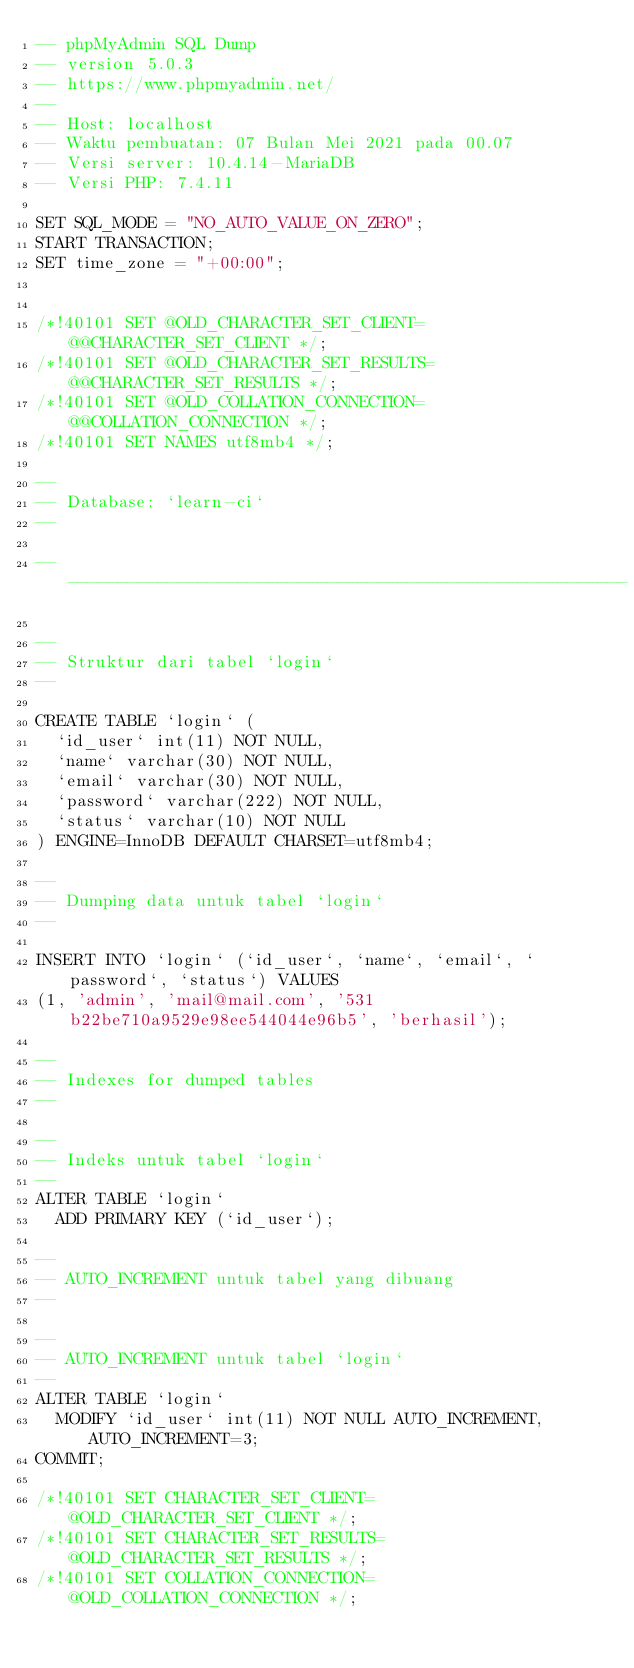<code> <loc_0><loc_0><loc_500><loc_500><_SQL_>-- phpMyAdmin SQL Dump
-- version 5.0.3
-- https://www.phpmyadmin.net/
--
-- Host: localhost
-- Waktu pembuatan: 07 Bulan Mei 2021 pada 00.07
-- Versi server: 10.4.14-MariaDB
-- Versi PHP: 7.4.11

SET SQL_MODE = "NO_AUTO_VALUE_ON_ZERO";
START TRANSACTION;
SET time_zone = "+00:00";


/*!40101 SET @OLD_CHARACTER_SET_CLIENT=@@CHARACTER_SET_CLIENT */;
/*!40101 SET @OLD_CHARACTER_SET_RESULTS=@@CHARACTER_SET_RESULTS */;
/*!40101 SET @OLD_COLLATION_CONNECTION=@@COLLATION_CONNECTION */;
/*!40101 SET NAMES utf8mb4 */;

--
-- Database: `learn-ci`
--

-- --------------------------------------------------------

--
-- Struktur dari tabel `login`
--

CREATE TABLE `login` (
  `id_user` int(11) NOT NULL,
  `name` varchar(30) NOT NULL,
  `email` varchar(30) NOT NULL,
  `password` varchar(222) NOT NULL,
  `status` varchar(10) NOT NULL
) ENGINE=InnoDB DEFAULT CHARSET=utf8mb4;

--
-- Dumping data untuk tabel `login`
--

INSERT INTO `login` (`id_user`, `name`, `email`, `password`, `status`) VALUES
(1, 'admin', 'mail@mail.com', '531b22be710a9529e98ee544044e96b5', 'berhasil');

--
-- Indexes for dumped tables
--

--
-- Indeks untuk tabel `login`
--
ALTER TABLE `login`
  ADD PRIMARY KEY (`id_user`);

--
-- AUTO_INCREMENT untuk tabel yang dibuang
--

--
-- AUTO_INCREMENT untuk tabel `login`
--
ALTER TABLE `login`
  MODIFY `id_user` int(11) NOT NULL AUTO_INCREMENT, AUTO_INCREMENT=3;
COMMIT;

/*!40101 SET CHARACTER_SET_CLIENT=@OLD_CHARACTER_SET_CLIENT */;
/*!40101 SET CHARACTER_SET_RESULTS=@OLD_CHARACTER_SET_RESULTS */;
/*!40101 SET COLLATION_CONNECTION=@OLD_COLLATION_CONNECTION */;
</code> 